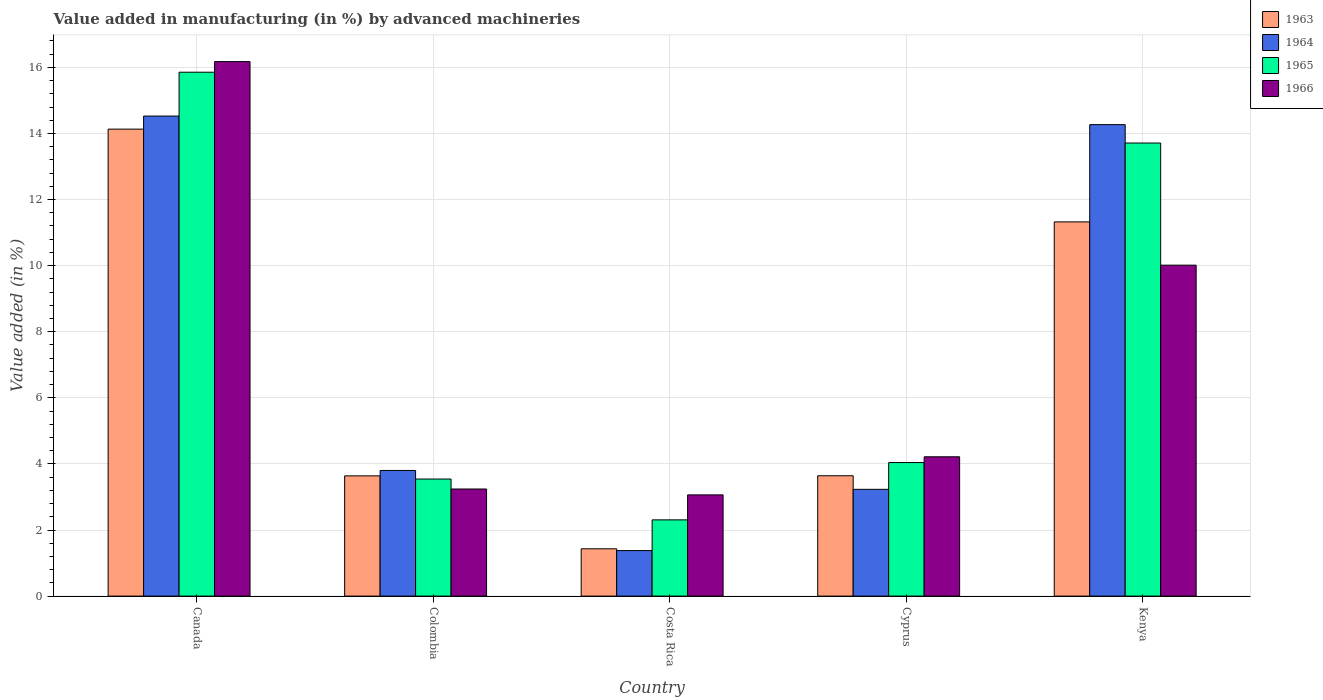How many groups of bars are there?
Provide a succinct answer. 5. How many bars are there on the 3rd tick from the left?
Your answer should be very brief. 4. What is the label of the 5th group of bars from the left?
Your answer should be very brief. Kenya. What is the percentage of value added in manufacturing by advanced machineries in 1965 in Colombia?
Give a very brief answer. 3.54. Across all countries, what is the maximum percentage of value added in manufacturing by advanced machineries in 1964?
Provide a succinct answer. 14.53. Across all countries, what is the minimum percentage of value added in manufacturing by advanced machineries in 1964?
Make the answer very short. 1.38. In which country was the percentage of value added in manufacturing by advanced machineries in 1963 minimum?
Offer a terse response. Costa Rica. What is the total percentage of value added in manufacturing by advanced machineries in 1964 in the graph?
Ensure brevity in your answer.  37.2. What is the difference between the percentage of value added in manufacturing by advanced machineries in 1964 in Canada and that in Costa Rica?
Your answer should be compact. 13.15. What is the difference between the percentage of value added in manufacturing by advanced machineries in 1966 in Kenya and the percentage of value added in manufacturing by advanced machineries in 1965 in Costa Rica?
Keep it short and to the point. 7.71. What is the average percentage of value added in manufacturing by advanced machineries in 1966 per country?
Give a very brief answer. 7.34. What is the difference between the percentage of value added in manufacturing by advanced machineries of/in 1964 and percentage of value added in manufacturing by advanced machineries of/in 1966 in Costa Rica?
Provide a succinct answer. -1.69. What is the ratio of the percentage of value added in manufacturing by advanced machineries in 1963 in Colombia to that in Cyprus?
Give a very brief answer. 1. What is the difference between the highest and the second highest percentage of value added in manufacturing by advanced machineries in 1964?
Keep it short and to the point. -10.72. What is the difference between the highest and the lowest percentage of value added in manufacturing by advanced machineries in 1964?
Your answer should be very brief. 13.15. Is it the case that in every country, the sum of the percentage of value added in manufacturing by advanced machineries in 1965 and percentage of value added in manufacturing by advanced machineries in 1963 is greater than the sum of percentage of value added in manufacturing by advanced machineries in 1964 and percentage of value added in manufacturing by advanced machineries in 1966?
Provide a succinct answer. No. What does the 3rd bar from the left in Canada represents?
Your answer should be very brief. 1965. What does the 2nd bar from the right in Cyprus represents?
Your answer should be compact. 1965. How many bars are there?
Provide a succinct answer. 20. How many countries are there in the graph?
Offer a very short reply. 5. What is the difference between two consecutive major ticks on the Y-axis?
Provide a succinct answer. 2. Are the values on the major ticks of Y-axis written in scientific E-notation?
Ensure brevity in your answer.  No. How many legend labels are there?
Your response must be concise. 4. How are the legend labels stacked?
Your answer should be compact. Vertical. What is the title of the graph?
Provide a succinct answer. Value added in manufacturing (in %) by advanced machineries. What is the label or title of the Y-axis?
Give a very brief answer. Value added (in %). What is the Value added (in %) in 1963 in Canada?
Offer a very short reply. 14.13. What is the Value added (in %) of 1964 in Canada?
Your response must be concise. 14.53. What is the Value added (in %) in 1965 in Canada?
Make the answer very short. 15.85. What is the Value added (in %) of 1966 in Canada?
Give a very brief answer. 16.17. What is the Value added (in %) in 1963 in Colombia?
Your answer should be compact. 3.64. What is the Value added (in %) of 1964 in Colombia?
Make the answer very short. 3.8. What is the Value added (in %) of 1965 in Colombia?
Your response must be concise. 3.54. What is the Value added (in %) in 1966 in Colombia?
Your answer should be very brief. 3.24. What is the Value added (in %) of 1963 in Costa Rica?
Your answer should be very brief. 1.43. What is the Value added (in %) of 1964 in Costa Rica?
Your response must be concise. 1.38. What is the Value added (in %) in 1965 in Costa Rica?
Keep it short and to the point. 2.31. What is the Value added (in %) in 1966 in Costa Rica?
Ensure brevity in your answer.  3.06. What is the Value added (in %) of 1963 in Cyprus?
Your answer should be very brief. 3.64. What is the Value added (in %) in 1964 in Cyprus?
Offer a terse response. 3.23. What is the Value added (in %) in 1965 in Cyprus?
Offer a terse response. 4.04. What is the Value added (in %) of 1966 in Cyprus?
Make the answer very short. 4.22. What is the Value added (in %) in 1963 in Kenya?
Keep it short and to the point. 11.32. What is the Value added (in %) of 1964 in Kenya?
Your response must be concise. 14.27. What is the Value added (in %) in 1965 in Kenya?
Provide a short and direct response. 13.71. What is the Value added (in %) of 1966 in Kenya?
Offer a very short reply. 10.01. Across all countries, what is the maximum Value added (in %) of 1963?
Ensure brevity in your answer.  14.13. Across all countries, what is the maximum Value added (in %) of 1964?
Offer a terse response. 14.53. Across all countries, what is the maximum Value added (in %) of 1965?
Keep it short and to the point. 15.85. Across all countries, what is the maximum Value added (in %) of 1966?
Give a very brief answer. 16.17. Across all countries, what is the minimum Value added (in %) in 1963?
Ensure brevity in your answer.  1.43. Across all countries, what is the minimum Value added (in %) of 1964?
Your answer should be very brief. 1.38. Across all countries, what is the minimum Value added (in %) in 1965?
Keep it short and to the point. 2.31. Across all countries, what is the minimum Value added (in %) of 1966?
Your answer should be very brief. 3.06. What is the total Value added (in %) in 1963 in the graph?
Offer a very short reply. 34.16. What is the total Value added (in %) in 1964 in the graph?
Keep it short and to the point. 37.2. What is the total Value added (in %) in 1965 in the graph?
Make the answer very short. 39.45. What is the total Value added (in %) of 1966 in the graph?
Ensure brevity in your answer.  36.71. What is the difference between the Value added (in %) of 1963 in Canada and that in Colombia?
Provide a short and direct response. 10.49. What is the difference between the Value added (in %) of 1964 in Canada and that in Colombia?
Your response must be concise. 10.72. What is the difference between the Value added (in %) in 1965 in Canada and that in Colombia?
Give a very brief answer. 12.31. What is the difference between the Value added (in %) in 1966 in Canada and that in Colombia?
Give a very brief answer. 12.93. What is the difference between the Value added (in %) of 1963 in Canada and that in Costa Rica?
Ensure brevity in your answer.  12.7. What is the difference between the Value added (in %) of 1964 in Canada and that in Costa Rica?
Your response must be concise. 13.15. What is the difference between the Value added (in %) of 1965 in Canada and that in Costa Rica?
Offer a terse response. 13.55. What is the difference between the Value added (in %) in 1966 in Canada and that in Costa Rica?
Offer a terse response. 13.11. What is the difference between the Value added (in %) in 1963 in Canada and that in Cyprus?
Your answer should be compact. 10.49. What is the difference between the Value added (in %) of 1964 in Canada and that in Cyprus?
Keep it short and to the point. 11.3. What is the difference between the Value added (in %) of 1965 in Canada and that in Cyprus?
Make the answer very short. 11.81. What is the difference between the Value added (in %) in 1966 in Canada and that in Cyprus?
Provide a succinct answer. 11.96. What is the difference between the Value added (in %) of 1963 in Canada and that in Kenya?
Offer a terse response. 2.81. What is the difference between the Value added (in %) in 1964 in Canada and that in Kenya?
Provide a short and direct response. 0.26. What is the difference between the Value added (in %) of 1965 in Canada and that in Kenya?
Your response must be concise. 2.14. What is the difference between the Value added (in %) of 1966 in Canada and that in Kenya?
Provide a succinct answer. 6.16. What is the difference between the Value added (in %) of 1963 in Colombia and that in Costa Rica?
Make the answer very short. 2.21. What is the difference between the Value added (in %) of 1964 in Colombia and that in Costa Rica?
Provide a succinct answer. 2.42. What is the difference between the Value added (in %) in 1965 in Colombia and that in Costa Rica?
Provide a short and direct response. 1.24. What is the difference between the Value added (in %) of 1966 in Colombia and that in Costa Rica?
Offer a terse response. 0.18. What is the difference between the Value added (in %) in 1963 in Colombia and that in Cyprus?
Your answer should be very brief. -0. What is the difference between the Value added (in %) in 1964 in Colombia and that in Cyprus?
Provide a short and direct response. 0.57. What is the difference between the Value added (in %) in 1965 in Colombia and that in Cyprus?
Make the answer very short. -0.5. What is the difference between the Value added (in %) of 1966 in Colombia and that in Cyprus?
Your response must be concise. -0.97. What is the difference between the Value added (in %) in 1963 in Colombia and that in Kenya?
Your response must be concise. -7.69. What is the difference between the Value added (in %) of 1964 in Colombia and that in Kenya?
Your response must be concise. -10.47. What is the difference between the Value added (in %) in 1965 in Colombia and that in Kenya?
Your answer should be very brief. -10.17. What is the difference between the Value added (in %) of 1966 in Colombia and that in Kenya?
Offer a terse response. -6.77. What is the difference between the Value added (in %) of 1963 in Costa Rica and that in Cyprus?
Provide a short and direct response. -2.21. What is the difference between the Value added (in %) of 1964 in Costa Rica and that in Cyprus?
Offer a terse response. -1.85. What is the difference between the Value added (in %) of 1965 in Costa Rica and that in Cyprus?
Offer a very short reply. -1.73. What is the difference between the Value added (in %) in 1966 in Costa Rica and that in Cyprus?
Keep it short and to the point. -1.15. What is the difference between the Value added (in %) of 1963 in Costa Rica and that in Kenya?
Keep it short and to the point. -9.89. What is the difference between the Value added (in %) in 1964 in Costa Rica and that in Kenya?
Your answer should be compact. -12.89. What is the difference between the Value added (in %) in 1965 in Costa Rica and that in Kenya?
Make the answer very short. -11.4. What is the difference between the Value added (in %) of 1966 in Costa Rica and that in Kenya?
Provide a succinct answer. -6.95. What is the difference between the Value added (in %) in 1963 in Cyprus and that in Kenya?
Ensure brevity in your answer.  -7.68. What is the difference between the Value added (in %) in 1964 in Cyprus and that in Kenya?
Your answer should be compact. -11.04. What is the difference between the Value added (in %) of 1965 in Cyprus and that in Kenya?
Your response must be concise. -9.67. What is the difference between the Value added (in %) of 1966 in Cyprus and that in Kenya?
Offer a terse response. -5.8. What is the difference between the Value added (in %) of 1963 in Canada and the Value added (in %) of 1964 in Colombia?
Provide a short and direct response. 10.33. What is the difference between the Value added (in %) in 1963 in Canada and the Value added (in %) in 1965 in Colombia?
Ensure brevity in your answer.  10.59. What is the difference between the Value added (in %) of 1963 in Canada and the Value added (in %) of 1966 in Colombia?
Offer a very short reply. 10.89. What is the difference between the Value added (in %) of 1964 in Canada and the Value added (in %) of 1965 in Colombia?
Your answer should be very brief. 10.98. What is the difference between the Value added (in %) in 1964 in Canada and the Value added (in %) in 1966 in Colombia?
Ensure brevity in your answer.  11.29. What is the difference between the Value added (in %) in 1965 in Canada and the Value added (in %) in 1966 in Colombia?
Provide a short and direct response. 12.61. What is the difference between the Value added (in %) in 1963 in Canada and the Value added (in %) in 1964 in Costa Rica?
Offer a very short reply. 12.75. What is the difference between the Value added (in %) of 1963 in Canada and the Value added (in %) of 1965 in Costa Rica?
Give a very brief answer. 11.82. What is the difference between the Value added (in %) of 1963 in Canada and the Value added (in %) of 1966 in Costa Rica?
Offer a terse response. 11.07. What is the difference between the Value added (in %) in 1964 in Canada and the Value added (in %) in 1965 in Costa Rica?
Your response must be concise. 12.22. What is the difference between the Value added (in %) of 1964 in Canada and the Value added (in %) of 1966 in Costa Rica?
Keep it short and to the point. 11.46. What is the difference between the Value added (in %) of 1965 in Canada and the Value added (in %) of 1966 in Costa Rica?
Provide a succinct answer. 12.79. What is the difference between the Value added (in %) in 1963 in Canada and the Value added (in %) in 1964 in Cyprus?
Give a very brief answer. 10.9. What is the difference between the Value added (in %) of 1963 in Canada and the Value added (in %) of 1965 in Cyprus?
Your answer should be very brief. 10.09. What is the difference between the Value added (in %) of 1963 in Canada and the Value added (in %) of 1966 in Cyprus?
Your answer should be compact. 9.92. What is the difference between the Value added (in %) in 1964 in Canada and the Value added (in %) in 1965 in Cyprus?
Provide a succinct answer. 10.49. What is the difference between the Value added (in %) in 1964 in Canada and the Value added (in %) in 1966 in Cyprus?
Keep it short and to the point. 10.31. What is the difference between the Value added (in %) of 1965 in Canada and the Value added (in %) of 1966 in Cyprus?
Ensure brevity in your answer.  11.64. What is the difference between the Value added (in %) in 1963 in Canada and the Value added (in %) in 1964 in Kenya?
Your answer should be very brief. -0.14. What is the difference between the Value added (in %) of 1963 in Canada and the Value added (in %) of 1965 in Kenya?
Your answer should be very brief. 0.42. What is the difference between the Value added (in %) in 1963 in Canada and the Value added (in %) in 1966 in Kenya?
Your answer should be compact. 4.12. What is the difference between the Value added (in %) in 1964 in Canada and the Value added (in %) in 1965 in Kenya?
Your response must be concise. 0.82. What is the difference between the Value added (in %) in 1964 in Canada and the Value added (in %) in 1966 in Kenya?
Keep it short and to the point. 4.51. What is the difference between the Value added (in %) in 1965 in Canada and the Value added (in %) in 1966 in Kenya?
Provide a succinct answer. 5.84. What is the difference between the Value added (in %) in 1963 in Colombia and the Value added (in %) in 1964 in Costa Rica?
Offer a very short reply. 2.26. What is the difference between the Value added (in %) in 1963 in Colombia and the Value added (in %) in 1965 in Costa Rica?
Your answer should be very brief. 1.33. What is the difference between the Value added (in %) of 1963 in Colombia and the Value added (in %) of 1966 in Costa Rica?
Provide a short and direct response. 0.57. What is the difference between the Value added (in %) in 1964 in Colombia and the Value added (in %) in 1965 in Costa Rica?
Provide a succinct answer. 1.49. What is the difference between the Value added (in %) in 1964 in Colombia and the Value added (in %) in 1966 in Costa Rica?
Offer a terse response. 0.74. What is the difference between the Value added (in %) in 1965 in Colombia and the Value added (in %) in 1966 in Costa Rica?
Your answer should be compact. 0.48. What is the difference between the Value added (in %) of 1963 in Colombia and the Value added (in %) of 1964 in Cyprus?
Offer a terse response. 0.41. What is the difference between the Value added (in %) of 1963 in Colombia and the Value added (in %) of 1965 in Cyprus?
Give a very brief answer. -0.4. What is the difference between the Value added (in %) in 1963 in Colombia and the Value added (in %) in 1966 in Cyprus?
Ensure brevity in your answer.  -0.58. What is the difference between the Value added (in %) of 1964 in Colombia and the Value added (in %) of 1965 in Cyprus?
Your answer should be very brief. -0.24. What is the difference between the Value added (in %) in 1964 in Colombia and the Value added (in %) in 1966 in Cyprus?
Your answer should be compact. -0.41. What is the difference between the Value added (in %) in 1965 in Colombia and the Value added (in %) in 1966 in Cyprus?
Offer a very short reply. -0.67. What is the difference between the Value added (in %) of 1963 in Colombia and the Value added (in %) of 1964 in Kenya?
Your response must be concise. -10.63. What is the difference between the Value added (in %) in 1963 in Colombia and the Value added (in %) in 1965 in Kenya?
Make the answer very short. -10.07. What is the difference between the Value added (in %) of 1963 in Colombia and the Value added (in %) of 1966 in Kenya?
Keep it short and to the point. -6.38. What is the difference between the Value added (in %) of 1964 in Colombia and the Value added (in %) of 1965 in Kenya?
Your answer should be very brief. -9.91. What is the difference between the Value added (in %) in 1964 in Colombia and the Value added (in %) in 1966 in Kenya?
Provide a succinct answer. -6.21. What is the difference between the Value added (in %) of 1965 in Colombia and the Value added (in %) of 1966 in Kenya?
Ensure brevity in your answer.  -6.47. What is the difference between the Value added (in %) of 1963 in Costa Rica and the Value added (in %) of 1964 in Cyprus?
Give a very brief answer. -1.8. What is the difference between the Value added (in %) of 1963 in Costa Rica and the Value added (in %) of 1965 in Cyprus?
Ensure brevity in your answer.  -2.61. What is the difference between the Value added (in %) in 1963 in Costa Rica and the Value added (in %) in 1966 in Cyprus?
Provide a short and direct response. -2.78. What is the difference between the Value added (in %) in 1964 in Costa Rica and the Value added (in %) in 1965 in Cyprus?
Your response must be concise. -2.66. What is the difference between the Value added (in %) of 1964 in Costa Rica and the Value added (in %) of 1966 in Cyprus?
Keep it short and to the point. -2.84. What is the difference between the Value added (in %) in 1965 in Costa Rica and the Value added (in %) in 1966 in Cyprus?
Offer a very short reply. -1.91. What is the difference between the Value added (in %) of 1963 in Costa Rica and the Value added (in %) of 1964 in Kenya?
Your response must be concise. -12.84. What is the difference between the Value added (in %) in 1963 in Costa Rica and the Value added (in %) in 1965 in Kenya?
Keep it short and to the point. -12.28. What is the difference between the Value added (in %) in 1963 in Costa Rica and the Value added (in %) in 1966 in Kenya?
Offer a very short reply. -8.58. What is the difference between the Value added (in %) in 1964 in Costa Rica and the Value added (in %) in 1965 in Kenya?
Provide a short and direct response. -12.33. What is the difference between the Value added (in %) of 1964 in Costa Rica and the Value added (in %) of 1966 in Kenya?
Your response must be concise. -8.64. What is the difference between the Value added (in %) of 1965 in Costa Rica and the Value added (in %) of 1966 in Kenya?
Your response must be concise. -7.71. What is the difference between the Value added (in %) of 1963 in Cyprus and the Value added (in %) of 1964 in Kenya?
Make the answer very short. -10.63. What is the difference between the Value added (in %) in 1963 in Cyprus and the Value added (in %) in 1965 in Kenya?
Keep it short and to the point. -10.07. What is the difference between the Value added (in %) in 1963 in Cyprus and the Value added (in %) in 1966 in Kenya?
Keep it short and to the point. -6.37. What is the difference between the Value added (in %) in 1964 in Cyprus and the Value added (in %) in 1965 in Kenya?
Your response must be concise. -10.48. What is the difference between the Value added (in %) of 1964 in Cyprus and the Value added (in %) of 1966 in Kenya?
Offer a terse response. -6.78. What is the difference between the Value added (in %) in 1965 in Cyprus and the Value added (in %) in 1966 in Kenya?
Your answer should be compact. -5.97. What is the average Value added (in %) in 1963 per country?
Offer a very short reply. 6.83. What is the average Value added (in %) of 1964 per country?
Keep it short and to the point. 7.44. What is the average Value added (in %) in 1965 per country?
Offer a terse response. 7.89. What is the average Value added (in %) of 1966 per country?
Provide a short and direct response. 7.34. What is the difference between the Value added (in %) of 1963 and Value added (in %) of 1964 in Canada?
Make the answer very short. -0.4. What is the difference between the Value added (in %) of 1963 and Value added (in %) of 1965 in Canada?
Offer a terse response. -1.72. What is the difference between the Value added (in %) in 1963 and Value added (in %) in 1966 in Canada?
Offer a very short reply. -2.04. What is the difference between the Value added (in %) in 1964 and Value added (in %) in 1965 in Canada?
Give a very brief answer. -1.33. What is the difference between the Value added (in %) in 1964 and Value added (in %) in 1966 in Canada?
Your response must be concise. -1.65. What is the difference between the Value added (in %) of 1965 and Value added (in %) of 1966 in Canada?
Your answer should be compact. -0.32. What is the difference between the Value added (in %) in 1963 and Value added (in %) in 1964 in Colombia?
Your answer should be very brief. -0.16. What is the difference between the Value added (in %) in 1963 and Value added (in %) in 1965 in Colombia?
Make the answer very short. 0.1. What is the difference between the Value added (in %) in 1963 and Value added (in %) in 1966 in Colombia?
Your answer should be very brief. 0.4. What is the difference between the Value added (in %) in 1964 and Value added (in %) in 1965 in Colombia?
Provide a short and direct response. 0.26. What is the difference between the Value added (in %) in 1964 and Value added (in %) in 1966 in Colombia?
Ensure brevity in your answer.  0.56. What is the difference between the Value added (in %) in 1965 and Value added (in %) in 1966 in Colombia?
Provide a succinct answer. 0.3. What is the difference between the Value added (in %) of 1963 and Value added (in %) of 1964 in Costa Rica?
Your answer should be very brief. 0.05. What is the difference between the Value added (in %) in 1963 and Value added (in %) in 1965 in Costa Rica?
Make the answer very short. -0.88. What is the difference between the Value added (in %) in 1963 and Value added (in %) in 1966 in Costa Rica?
Give a very brief answer. -1.63. What is the difference between the Value added (in %) in 1964 and Value added (in %) in 1965 in Costa Rica?
Make the answer very short. -0.93. What is the difference between the Value added (in %) in 1964 and Value added (in %) in 1966 in Costa Rica?
Provide a succinct answer. -1.69. What is the difference between the Value added (in %) in 1965 and Value added (in %) in 1966 in Costa Rica?
Your answer should be compact. -0.76. What is the difference between the Value added (in %) in 1963 and Value added (in %) in 1964 in Cyprus?
Your answer should be very brief. 0.41. What is the difference between the Value added (in %) of 1963 and Value added (in %) of 1965 in Cyprus?
Keep it short and to the point. -0.4. What is the difference between the Value added (in %) in 1963 and Value added (in %) in 1966 in Cyprus?
Your answer should be very brief. -0.57. What is the difference between the Value added (in %) of 1964 and Value added (in %) of 1965 in Cyprus?
Offer a very short reply. -0.81. What is the difference between the Value added (in %) of 1964 and Value added (in %) of 1966 in Cyprus?
Offer a very short reply. -0.98. What is the difference between the Value added (in %) in 1965 and Value added (in %) in 1966 in Cyprus?
Give a very brief answer. -0.17. What is the difference between the Value added (in %) in 1963 and Value added (in %) in 1964 in Kenya?
Provide a short and direct response. -2.94. What is the difference between the Value added (in %) in 1963 and Value added (in %) in 1965 in Kenya?
Your response must be concise. -2.39. What is the difference between the Value added (in %) of 1963 and Value added (in %) of 1966 in Kenya?
Your answer should be compact. 1.31. What is the difference between the Value added (in %) in 1964 and Value added (in %) in 1965 in Kenya?
Your answer should be compact. 0.56. What is the difference between the Value added (in %) of 1964 and Value added (in %) of 1966 in Kenya?
Make the answer very short. 4.25. What is the difference between the Value added (in %) of 1965 and Value added (in %) of 1966 in Kenya?
Offer a terse response. 3.7. What is the ratio of the Value added (in %) of 1963 in Canada to that in Colombia?
Provide a succinct answer. 3.88. What is the ratio of the Value added (in %) in 1964 in Canada to that in Colombia?
Your answer should be very brief. 3.82. What is the ratio of the Value added (in %) in 1965 in Canada to that in Colombia?
Make the answer very short. 4.48. What is the ratio of the Value added (in %) of 1966 in Canada to that in Colombia?
Offer a terse response. 4.99. What is the ratio of the Value added (in %) of 1963 in Canada to that in Costa Rica?
Your response must be concise. 9.87. What is the ratio of the Value added (in %) of 1964 in Canada to that in Costa Rica?
Ensure brevity in your answer.  10.54. What is the ratio of the Value added (in %) of 1965 in Canada to that in Costa Rica?
Give a very brief answer. 6.87. What is the ratio of the Value added (in %) of 1966 in Canada to that in Costa Rica?
Offer a very short reply. 5.28. What is the ratio of the Value added (in %) in 1963 in Canada to that in Cyprus?
Ensure brevity in your answer.  3.88. What is the ratio of the Value added (in %) of 1964 in Canada to that in Cyprus?
Your answer should be compact. 4.5. What is the ratio of the Value added (in %) of 1965 in Canada to that in Cyprus?
Offer a very short reply. 3.92. What is the ratio of the Value added (in %) of 1966 in Canada to that in Cyprus?
Provide a succinct answer. 3.84. What is the ratio of the Value added (in %) of 1963 in Canada to that in Kenya?
Provide a short and direct response. 1.25. What is the ratio of the Value added (in %) of 1964 in Canada to that in Kenya?
Your answer should be very brief. 1.02. What is the ratio of the Value added (in %) of 1965 in Canada to that in Kenya?
Give a very brief answer. 1.16. What is the ratio of the Value added (in %) of 1966 in Canada to that in Kenya?
Offer a very short reply. 1.62. What is the ratio of the Value added (in %) in 1963 in Colombia to that in Costa Rica?
Your response must be concise. 2.54. What is the ratio of the Value added (in %) of 1964 in Colombia to that in Costa Rica?
Your response must be concise. 2.76. What is the ratio of the Value added (in %) of 1965 in Colombia to that in Costa Rica?
Your response must be concise. 1.54. What is the ratio of the Value added (in %) in 1966 in Colombia to that in Costa Rica?
Ensure brevity in your answer.  1.06. What is the ratio of the Value added (in %) in 1964 in Colombia to that in Cyprus?
Ensure brevity in your answer.  1.18. What is the ratio of the Value added (in %) of 1965 in Colombia to that in Cyprus?
Give a very brief answer. 0.88. What is the ratio of the Value added (in %) in 1966 in Colombia to that in Cyprus?
Your answer should be very brief. 0.77. What is the ratio of the Value added (in %) of 1963 in Colombia to that in Kenya?
Make the answer very short. 0.32. What is the ratio of the Value added (in %) of 1964 in Colombia to that in Kenya?
Your answer should be compact. 0.27. What is the ratio of the Value added (in %) in 1965 in Colombia to that in Kenya?
Give a very brief answer. 0.26. What is the ratio of the Value added (in %) in 1966 in Colombia to that in Kenya?
Your answer should be compact. 0.32. What is the ratio of the Value added (in %) in 1963 in Costa Rica to that in Cyprus?
Your response must be concise. 0.39. What is the ratio of the Value added (in %) in 1964 in Costa Rica to that in Cyprus?
Provide a short and direct response. 0.43. What is the ratio of the Value added (in %) of 1965 in Costa Rica to that in Cyprus?
Provide a short and direct response. 0.57. What is the ratio of the Value added (in %) of 1966 in Costa Rica to that in Cyprus?
Your response must be concise. 0.73. What is the ratio of the Value added (in %) of 1963 in Costa Rica to that in Kenya?
Offer a terse response. 0.13. What is the ratio of the Value added (in %) in 1964 in Costa Rica to that in Kenya?
Keep it short and to the point. 0.1. What is the ratio of the Value added (in %) in 1965 in Costa Rica to that in Kenya?
Offer a very short reply. 0.17. What is the ratio of the Value added (in %) of 1966 in Costa Rica to that in Kenya?
Make the answer very short. 0.31. What is the ratio of the Value added (in %) of 1963 in Cyprus to that in Kenya?
Your response must be concise. 0.32. What is the ratio of the Value added (in %) of 1964 in Cyprus to that in Kenya?
Ensure brevity in your answer.  0.23. What is the ratio of the Value added (in %) of 1965 in Cyprus to that in Kenya?
Offer a very short reply. 0.29. What is the ratio of the Value added (in %) of 1966 in Cyprus to that in Kenya?
Keep it short and to the point. 0.42. What is the difference between the highest and the second highest Value added (in %) of 1963?
Ensure brevity in your answer.  2.81. What is the difference between the highest and the second highest Value added (in %) of 1964?
Give a very brief answer. 0.26. What is the difference between the highest and the second highest Value added (in %) in 1965?
Ensure brevity in your answer.  2.14. What is the difference between the highest and the second highest Value added (in %) of 1966?
Your answer should be very brief. 6.16. What is the difference between the highest and the lowest Value added (in %) of 1963?
Offer a terse response. 12.7. What is the difference between the highest and the lowest Value added (in %) of 1964?
Keep it short and to the point. 13.15. What is the difference between the highest and the lowest Value added (in %) in 1965?
Offer a terse response. 13.55. What is the difference between the highest and the lowest Value added (in %) in 1966?
Make the answer very short. 13.11. 